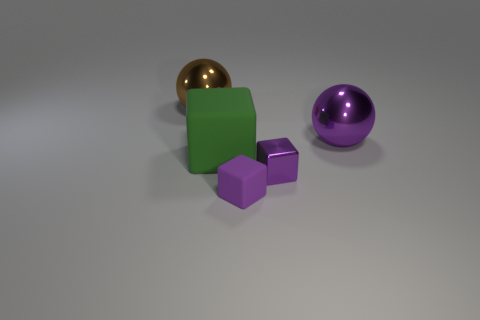The small thing that is the same color as the shiny block is what shape? The small object that shares the vibrant purple hue with the shiny sphere to the right is a cube. 